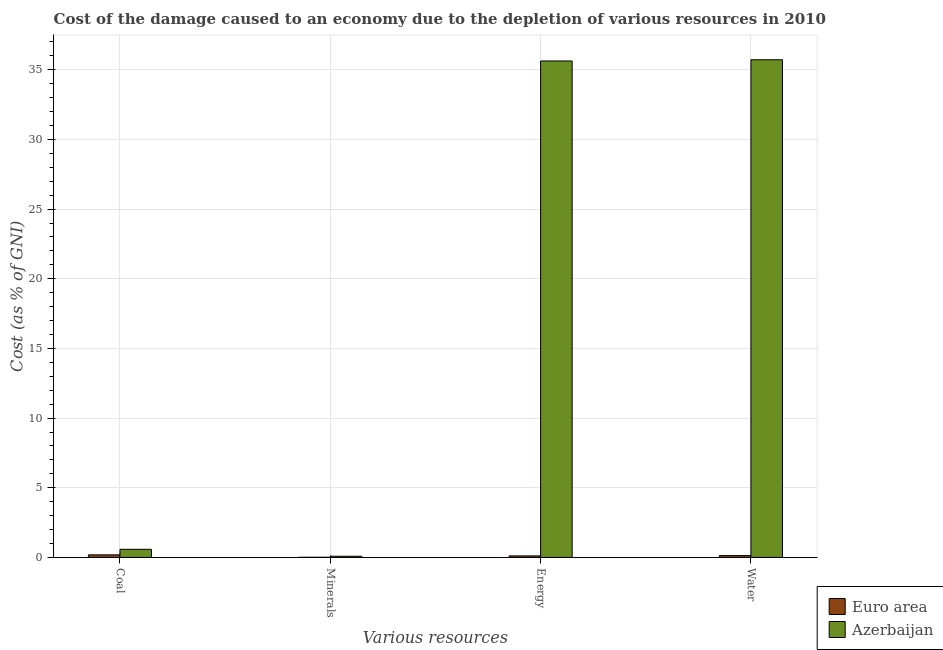How many different coloured bars are there?
Provide a succinct answer. 2. How many bars are there on the 3rd tick from the left?
Provide a succinct answer. 2. What is the label of the 3rd group of bars from the left?
Give a very brief answer. Energy. What is the cost of damage due to depletion of water in Azerbaijan?
Ensure brevity in your answer.  35.72. Across all countries, what is the maximum cost of damage due to depletion of minerals?
Your response must be concise. 0.09. Across all countries, what is the minimum cost of damage due to depletion of minerals?
Ensure brevity in your answer.  0.01. In which country was the cost of damage due to depletion of energy maximum?
Offer a terse response. Azerbaijan. In which country was the cost of damage due to depletion of coal minimum?
Your answer should be compact. Euro area. What is the total cost of damage due to depletion of water in the graph?
Your answer should be very brief. 35.85. What is the difference between the cost of damage due to depletion of water in Euro area and that in Azerbaijan?
Your response must be concise. -35.59. What is the difference between the cost of damage due to depletion of minerals in Euro area and the cost of damage due to depletion of energy in Azerbaijan?
Your answer should be very brief. -35.62. What is the average cost of damage due to depletion of water per country?
Your answer should be compact. 17.92. What is the difference between the cost of damage due to depletion of water and cost of damage due to depletion of minerals in Euro area?
Your answer should be compact. 0.12. In how many countries, is the cost of damage due to depletion of energy greater than 36 %?
Give a very brief answer. 0. What is the ratio of the cost of damage due to depletion of energy in Euro area to that in Azerbaijan?
Provide a short and direct response. 0. Is the cost of damage due to depletion of energy in Euro area less than that in Azerbaijan?
Ensure brevity in your answer.  Yes. What is the difference between the highest and the second highest cost of damage due to depletion of water?
Your answer should be very brief. 35.59. What is the difference between the highest and the lowest cost of damage due to depletion of energy?
Offer a very short reply. 35.52. What does the 2nd bar from the left in Coal represents?
Your response must be concise. Azerbaijan. What is the difference between two consecutive major ticks on the Y-axis?
Make the answer very short. 5. Are the values on the major ticks of Y-axis written in scientific E-notation?
Offer a very short reply. No. Does the graph contain grids?
Your answer should be very brief. Yes. How many legend labels are there?
Your response must be concise. 2. How are the legend labels stacked?
Keep it short and to the point. Vertical. What is the title of the graph?
Keep it short and to the point. Cost of the damage caused to an economy due to the depletion of various resources in 2010 . What is the label or title of the X-axis?
Make the answer very short. Various resources. What is the label or title of the Y-axis?
Your response must be concise. Cost (as % of GNI). What is the Cost (as % of GNI) of Euro area in Coal?
Offer a very short reply. 0.18. What is the Cost (as % of GNI) of Azerbaijan in Coal?
Provide a short and direct response. 0.58. What is the Cost (as % of GNI) of Euro area in Minerals?
Ensure brevity in your answer.  0.01. What is the Cost (as % of GNI) in Azerbaijan in Minerals?
Your answer should be very brief. 0.09. What is the Cost (as % of GNI) in Euro area in Energy?
Offer a very short reply. 0.11. What is the Cost (as % of GNI) in Azerbaijan in Energy?
Make the answer very short. 35.63. What is the Cost (as % of GNI) in Euro area in Water?
Keep it short and to the point. 0.13. What is the Cost (as % of GNI) of Azerbaijan in Water?
Keep it short and to the point. 35.72. Across all Various resources, what is the maximum Cost (as % of GNI) of Euro area?
Your answer should be compact. 0.18. Across all Various resources, what is the maximum Cost (as % of GNI) in Azerbaijan?
Your answer should be very brief. 35.72. Across all Various resources, what is the minimum Cost (as % of GNI) in Euro area?
Make the answer very short. 0.01. Across all Various resources, what is the minimum Cost (as % of GNI) in Azerbaijan?
Your answer should be very brief. 0.09. What is the total Cost (as % of GNI) of Euro area in the graph?
Offer a terse response. 0.44. What is the total Cost (as % of GNI) of Azerbaijan in the graph?
Your answer should be compact. 72.02. What is the difference between the Cost (as % of GNI) in Euro area in Coal and that in Minerals?
Keep it short and to the point. 0.17. What is the difference between the Cost (as % of GNI) in Azerbaijan in Coal and that in Minerals?
Your answer should be compact. 0.5. What is the difference between the Cost (as % of GNI) in Euro area in Coal and that in Energy?
Provide a short and direct response. 0.08. What is the difference between the Cost (as % of GNI) in Azerbaijan in Coal and that in Energy?
Offer a very short reply. -35.05. What is the difference between the Cost (as % of GNI) in Euro area in Coal and that in Water?
Your answer should be very brief. 0.05. What is the difference between the Cost (as % of GNI) of Azerbaijan in Coal and that in Water?
Make the answer very short. -35.14. What is the difference between the Cost (as % of GNI) of Euro area in Minerals and that in Energy?
Give a very brief answer. -0.1. What is the difference between the Cost (as % of GNI) of Azerbaijan in Minerals and that in Energy?
Offer a very short reply. -35.55. What is the difference between the Cost (as % of GNI) of Euro area in Minerals and that in Water?
Your answer should be very brief. -0.12. What is the difference between the Cost (as % of GNI) in Azerbaijan in Minerals and that in Water?
Your response must be concise. -35.63. What is the difference between the Cost (as % of GNI) of Euro area in Energy and that in Water?
Give a very brief answer. -0.02. What is the difference between the Cost (as % of GNI) in Azerbaijan in Energy and that in Water?
Your answer should be compact. -0.09. What is the difference between the Cost (as % of GNI) of Euro area in Coal and the Cost (as % of GNI) of Azerbaijan in Minerals?
Provide a short and direct response. 0.1. What is the difference between the Cost (as % of GNI) of Euro area in Coal and the Cost (as % of GNI) of Azerbaijan in Energy?
Keep it short and to the point. -35.45. What is the difference between the Cost (as % of GNI) of Euro area in Coal and the Cost (as % of GNI) of Azerbaijan in Water?
Offer a very short reply. -35.53. What is the difference between the Cost (as % of GNI) of Euro area in Minerals and the Cost (as % of GNI) of Azerbaijan in Energy?
Your answer should be compact. -35.62. What is the difference between the Cost (as % of GNI) of Euro area in Minerals and the Cost (as % of GNI) of Azerbaijan in Water?
Offer a terse response. -35.71. What is the difference between the Cost (as % of GNI) of Euro area in Energy and the Cost (as % of GNI) of Azerbaijan in Water?
Offer a very short reply. -35.61. What is the average Cost (as % of GNI) of Euro area per Various resources?
Your response must be concise. 0.11. What is the average Cost (as % of GNI) in Azerbaijan per Various resources?
Your answer should be compact. 18.01. What is the difference between the Cost (as % of GNI) in Euro area and Cost (as % of GNI) in Azerbaijan in Coal?
Offer a terse response. -0.4. What is the difference between the Cost (as % of GNI) in Euro area and Cost (as % of GNI) in Azerbaijan in Minerals?
Give a very brief answer. -0.07. What is the difference between the Cost (as % of GNI) in Euro area and Cost (as % of GNI) in Azerbaijan in Energy?
Offer a terse response. -35.52. What is the difference between the Cost (as % of GNI) in Euro area and Cost (as % of GNI) in Azerbaijan in Water?
Provide a short and direct response. -35.59. What is the ratio of the Cost (as % of GNI) in Euro area in Coal to that in Minerals?
Offer a very short reply. 16.47. What is the ratio of the Cost (as % of GNI) in Azerbaijan in Coal to that in Minerals?
Offer a terse response. 6.84. What is the ratio of the Cost (as % of GNI) of Euro area in Coal to that in Energy?
Ensure brevity in your answer.  1.69. What is the ratio of the Cost (as % of GNI) of Azerbaijan in Coal to that in Energy?
Provide a short and direct response. 0.02. What is the ratio of the Cost (as % of GNI) of Euro area in Coal to that in Water?
Your answer should be very brief. 1.41. What is the ratio of the Cost (as % of GNI) in Azerbaijan in Coal to that in Water?
Make the answer very short. 0.02. What is the ratio of the Cost (as % of GNI) of Euro area in Minerals to that in Energy?
Provide a short and direct response. 0.1. What is the ratio of the Cost (as % of GNI) of Azerbaijan in Minerals to that in Energy?
Offer a very short reply. 0. What is the ratio of the Cost (as % of GNI) of Euro area in Minerals to that in Water?
Provide a succinct answer. 0.09. What is the ratio of the Cost (as % of GNI) of Azerbaijan in Minerals to that in Water?
Offer a very short reply. 0. What is the ratio of the Cost (as % of GNI) in Euro area in Energy to that in Water?
Offer a terse response. 0.83. What is the difference between the highest and the second highest Cost (as % of GNI) in Euro area?
Keep it short and to the point. 0.05. What is the difference between the highest and the second highest Cost (as % of GNI) in Azerbaijan?
Ensure brevity in your answer.  0.09. What is the difference between the highest and the lowest Cost (as % of GNI) of Euro area?
Offer a terse response. 0.17. What is the difference between the highest and the lowest Cost (as % of GNI) of Azerbaijan?
Your answer should be compact. 35.63. 